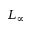Convert formula to latex. <formula><loc_0><loc_0><loc_500><loc_500>L _ { \infty }</formula> 